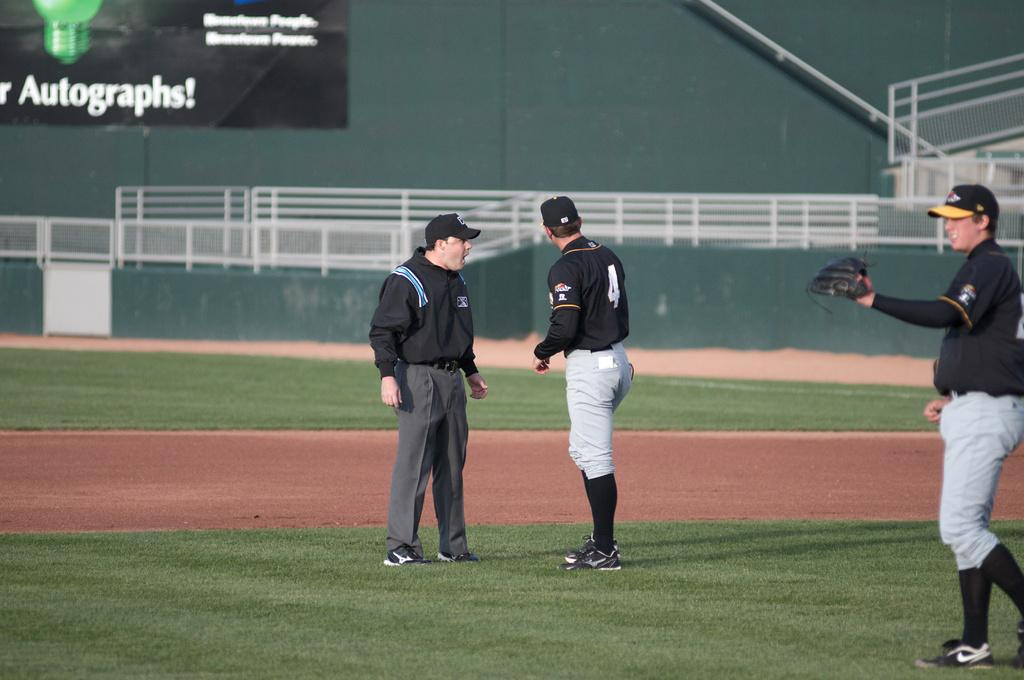<image>
Create a compact narrative representing the image presented. Baseball player #4 talks to his coach on the field with a sign that says Autographs! in the background. 